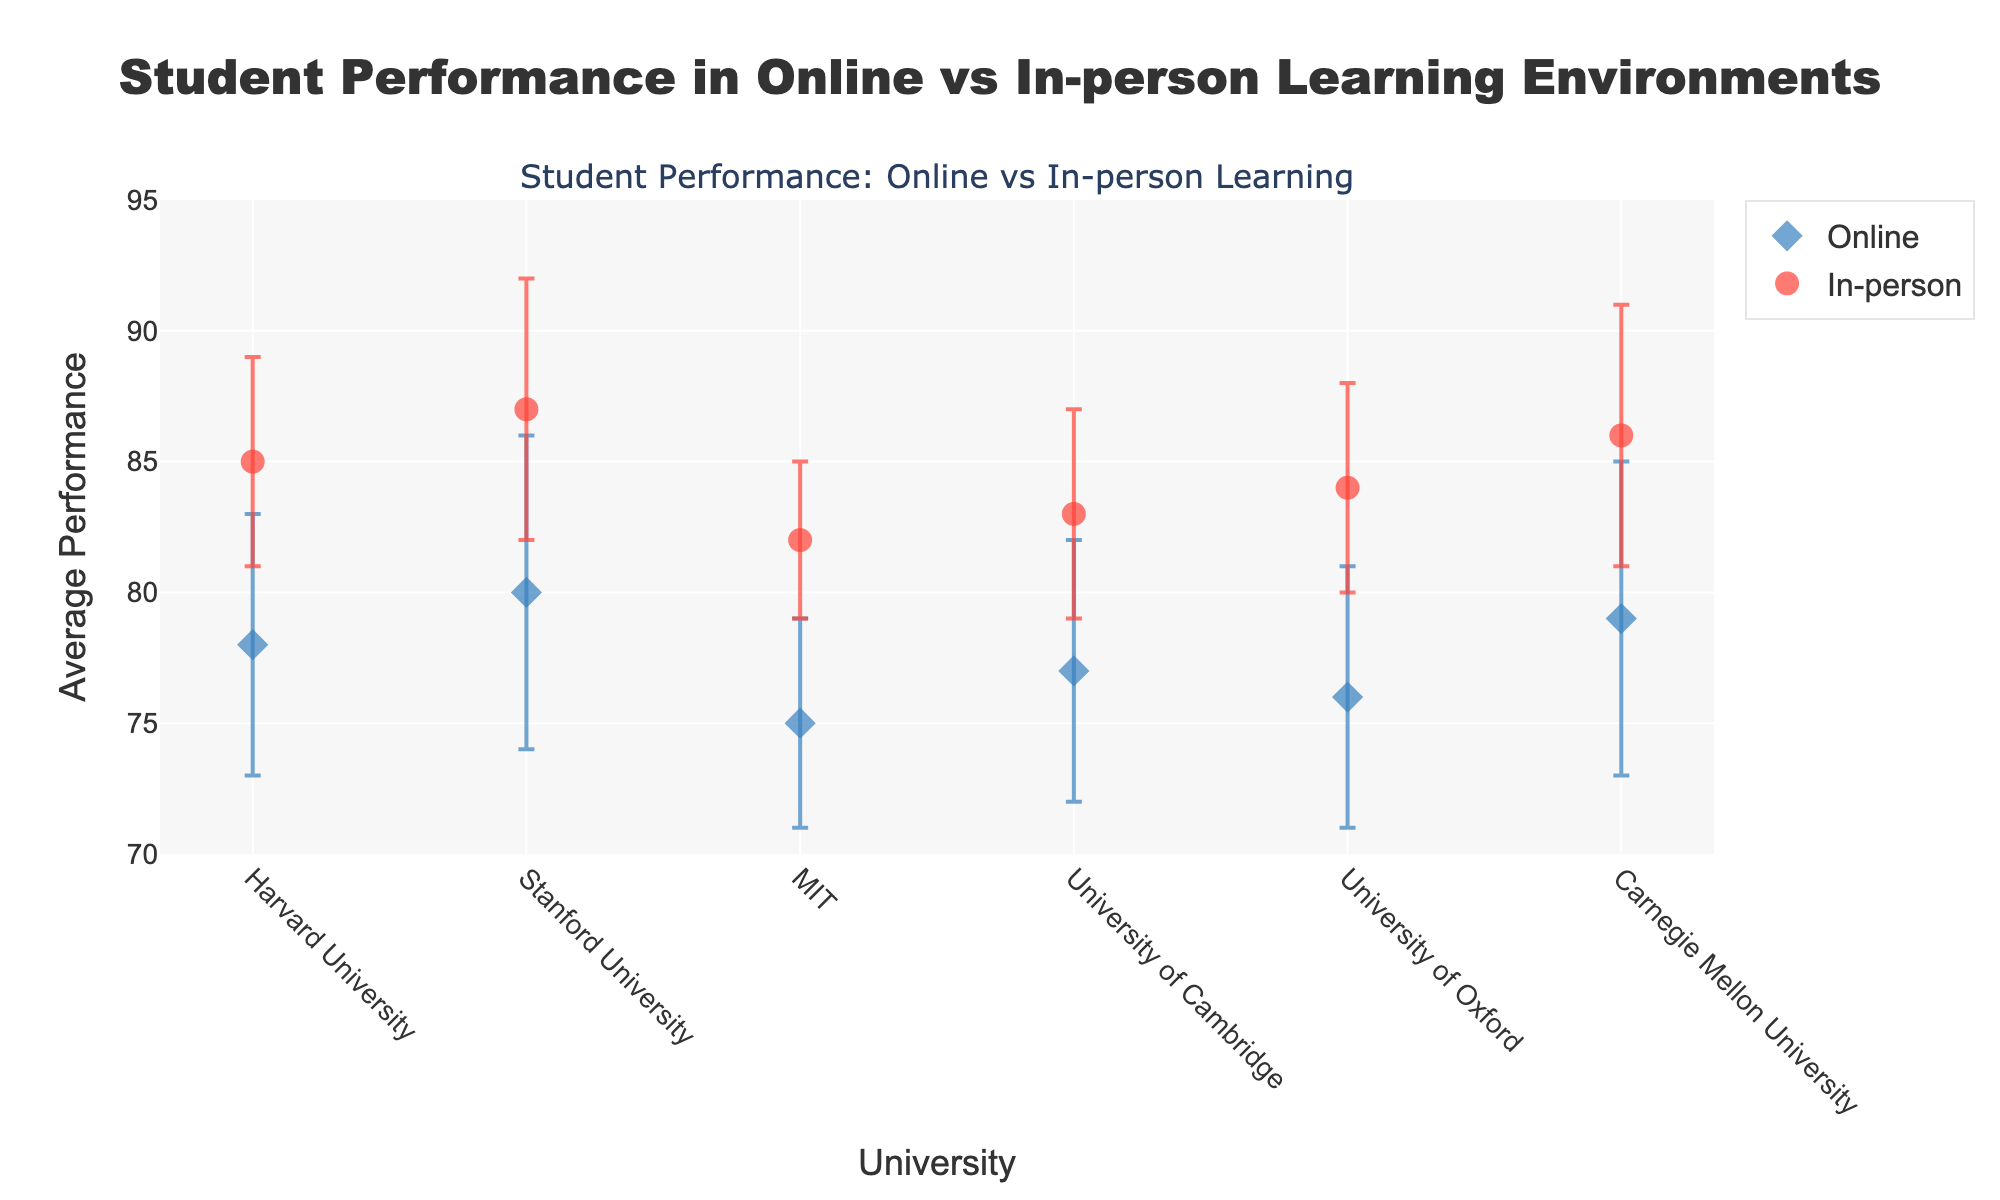How many universities are represented in the figure? Count the distinct universities shown on the x-axis. There are six universities: Harvard University, Stanford University, MIT, University of Cambridge, University of Oxford, and Carnegie Mellon University.
Answer: 6 What is the main title of the figure? Look at the top-center part of the figure where the title is located. The main title is "Student Performance in Online vs In-person Learning Environments."
Answer: Student Performance in Online vs In-person Learning Environments Which university has the highest average performance for online learning? Identify the y-values (average performance) for online learning and find the highest value. Stanford University has the highest average performance of 80 for online learning.
Answer: Stanford University What is the difference in average performance between online and in-person learning at MIT? Locate MIT on the x-axis and subtract the y-value (average performance) of online learning from in-person learning. The difference is 82 - 75 = 7.
Answer: 7 Which mode of learning has a higher average performance at Harvard University? Compare the y-values (average performance) for both online and in-person learning modes at Harvard University. In-person learning has a higher average performance of 85 compared to online’s 78.
Answer: In-person Looking at Carnegie Mellon University, what is the range of student performance for online learning? Calculate the range by adding and subtracting the standard deviation from the average performance for online learning. The range is 79 ± 6, so it’s from 73 to 85.
Answer: 73 to 85 How do the error bars for in-person learning at University of Oxford compare to those at Stanford University? Compare the lengths of the error bars (which represent standard deviations) for University of Oxford and Stanford University in-person learning modes. Both have an error bar (standard deviation) of 4.
Answer: They are equal For University of Cambridge, what are the average performances for online and in-person learning combined? Add the average performances for online and in-person learning and then divide by 2. The average combined performance is (77 + 83) / 2 = 80.
Answer: 80 Which university shows the smallest difference in average performance between online and in-person learning? Calculate the differences for each university and identify the smallest. University of Cambridge has the smallest difference of 83 - 77 = 6.
Answer: University of Cambridge Considering all universities, which learning mode generally shows higher average performance? Compare the overall trend of average performances between online and in-person learning modes. In-person learning generally shows higher average performance.
Answer: In-person 